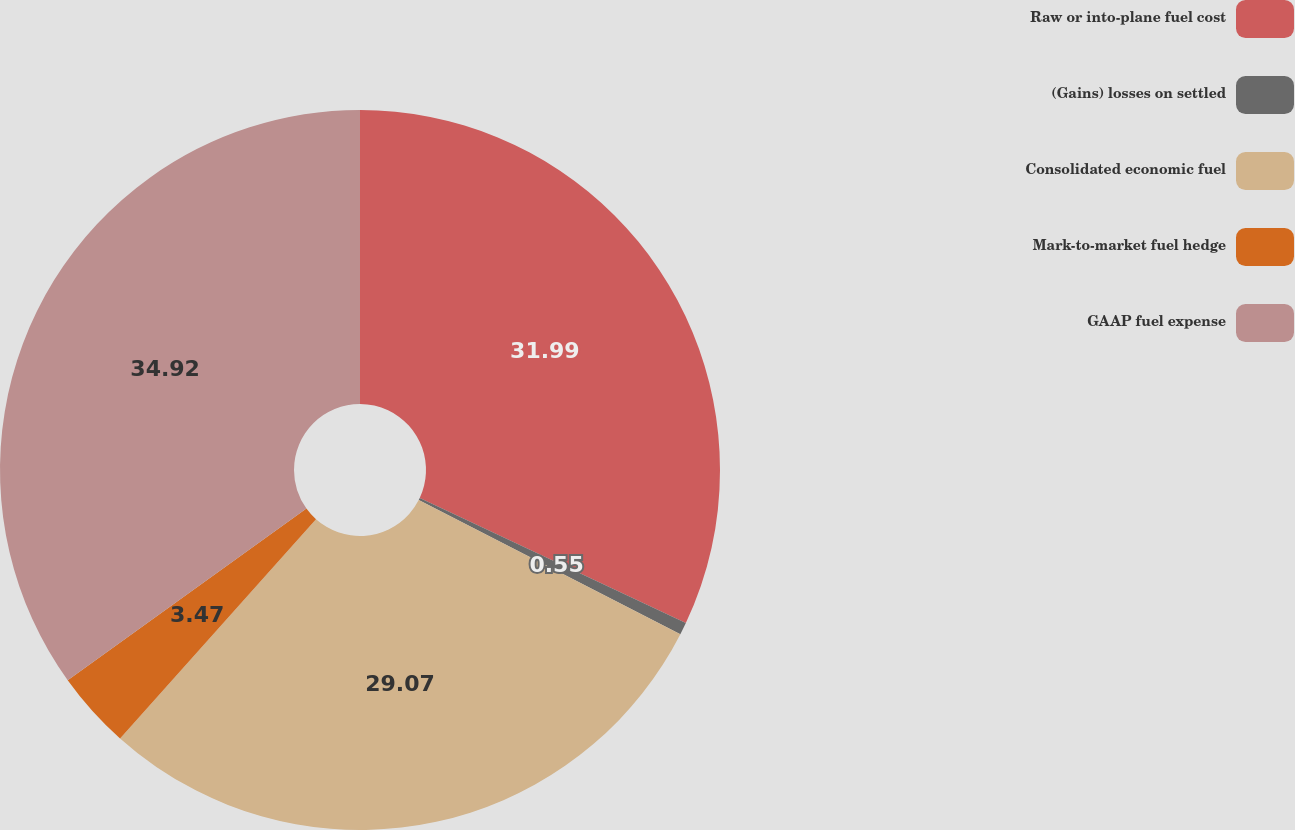Convert chart. <chart><loc_0><loc_0><loc_500><loc_500><pie_chart><fcel>Raw or into-plane fuel cost<fcel>(Gains) losses on settled<fcel>Consolidated economic fuel<fcel>Mark-to-market fuel hedge<fcel>GAAP fuel expense<nl><fcel>31.99%<fcel>0.55%<fcel>29.07%<fcel>3.47%<fcel>34.92%<nl></chart> 